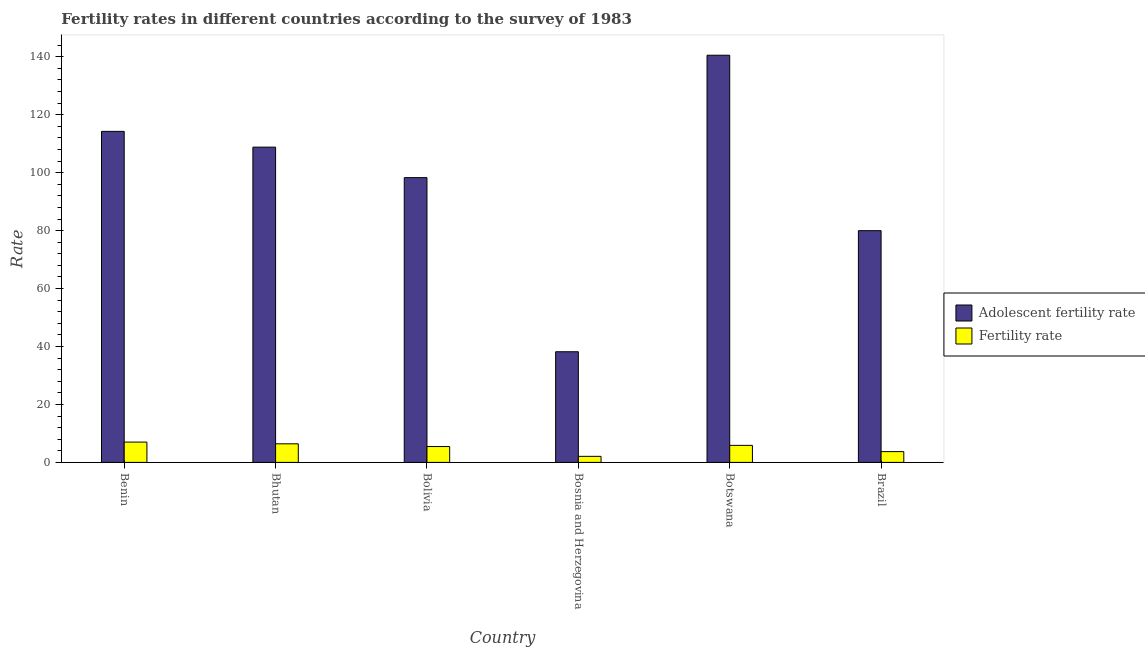How many different coloured bars are there?
Provide a short and direct response. 2. How many groups of bars are there?
Offer a very short reply. 6. Are the number of bars per tick equal to the number of legend labels?
Provide a succinct answer. Yes. Are the number of bars on each tick of the X-axis equal?
Make the answer very short. Yes. How many bars are there on the 6th tick from the right?
Provide a succinct answer. 2. What is the label of the 6th group of bars from the left?
Make the answer very short. Brazil. What is the fertility rate in Benin?
Keep it short and to the point. 7.01. Across all countries, what is the maximum fertility rate?
Ensure brevity in your answer.  7.01. Across all countries, what is the minimum fertility rate?
Keep it short and to the point. 2.09. In which country was the fertility rate maximum?
Your response must be concise. Benin. In which country was the fertility rate minimum?
Give a very brief answer. Bosnia and Herzegovina. What is the total fertility rate in the graph?
Offer a very short reply. 30.58. What is the difference between the adolescent fertility rate in Bosnia and Herzegovina and that in Brazil?
Your response must be concise. -41.79. What is the difference between the fertility rate in Bhutan and the adolescent fertility rate in Bosnia and Herzegovina?
Make the answer very short. -31.78. What is the average adolescent fertility rate per country?
Make the answer very short. 96.68. What is the difference between the adolescent fertility rate and fertility rate in Benin?
Ensure brevity in your answer.  107.25. In how many countries, is the adolescent fertility rate greater than 8 ?
Your answer should be very brief. 6. What is the ratio of the fertility rate in Bhutan to that in Botswana?
Provide a short and direct response. 1.09. Is the difference between the fertility rate in Bhutan and Brazil greater than the difference between the adolescent fertility rate in Bhutan and Brazil?
Your answer should be compact. No. What is the difference between the highest and the second highest adolescent fertility rate?
Ensure brevity in your answer.  26.28. What is the difference between the highest and the lowest fertility rate?
Offer a very short reply. 4.92. In how many countries, is the fertility rate greater than the average fertility rate taken over all countries?
Give a very brief answer. 4. What does the 2nd bar from the left in Brazil represents?
Your answer should be compact. Fertility rate. What does the 2nd bar from the right in Brazil represents?
Keep it short and to the point. Adolescent fertility rate. Are all the bars in the graph horizontal?
Provide a succinct answer. No. What is the difference between two consecutive major ticks on the Y-axis?
Make the answer very short. 20. Are the values on the major ticks of Y-axis written in scientific E-notation?
Keep it short and to the point. No. Does the graph contain grids?
Your answer should be compact. No. What is the title of the graph?
Give a very brief answer. Fertility rates in different countries according to the survey of 1983. What is the label or title of the X-axis?
Your answer should be very brief. Country. What is the label or title of the Y-axis?
Your answer should be very brief. Rate. What is the Rate in Adolescent fertility rate in Benin?
Offer a very short reply. 114.26. What is the Rate of Fertility rate in Benin?
Your answer should be very brief. 7.01. What is the Rate in Adolescent fertility rate in Bhutan?
Your answer should be very brief. 108.82. What is the Rate of Fertility rate in Bhutan?
Offer a terse response. 6.41. What is the Rate of Adolescent fertility rate in Bolivia?
Provide a short and direct response. 98.29. What is the Rate in Fertility rate in Bolivia?
Give a very brief answer. 5.47. What is the Rate of Adolescent fertility rate in Bosnia and Herzegovina?
Ensure brevity in your answer.  38.19. What is the Rate of Fertility rate in Bosnia and Herzegovina?
Your answer should be very brief. 2.09. What is the Rate of Adolescent fertility rate in Botswana?
Give a very brief answer. 140.54. What is the Rate in Fertility rate in Botswana?
Ensure brevity in your answer.  5.88. What is the Rate of Adolescent fertility rate in Brazil?
Offer a very short reply. 79.99. What is the Rate of Fertility rate in Brazil?
Offer a very short reply. 3.72. Across all countries, what is the maximum Rate in Adolescent fertility rate?
Your answer should be very brief. 140.54. Across all countries, what is the maximum Rate in Fertility rate?
Give a very brief answer. 7.01. Across all countries, what is the minimum Rate in Adolescent fertility rate?
Ensure brevity in your answer.  38.19. Across all countries, what is the minimum Rate of Fertility rate?
Make the answer very short. 2.09. What is the total Rate of Adolescent fertility rate in the graph?
Provide a succinct answer. 580.1. What is the total Rate of Fertility rate in the graph?
Ensure brevity in your answer.  30.58. What is the difference between the Rate in Adolescent fertility rate in Benin and that in Bhutan?
Your answer should be very brief. 5.44. What is the difference between the Rate of Fertility rate in Benin and that in Bhutan?
Give a very brief answer. 0.6. What is the difference between the Rate of Adolescent fertility rate in Benin and that in Bolivia?
Your answer should be compact. 15.97. What is the difference between the Rate of Fertility rate in Benin and that in Bolivia?
Provide a succinct answer. 1.54. What is the difference between the Rate of Adolescent fertility rate in Benin and that in Bosnia and Herzegovina?
Offer a very short reply. 76.07. What is the difference between the Rate in Fertility rate in Benin and that in Bosnia and Herzegovina?
Your response must be concise. 4.92. What is the difference between the Rate of Adolescent fertility rate in Benin and that in Botswana?
Ensure brevity in your answer.  -26.28. What is the difference between the Rate of Fertility rate in Benin and that in Botswana?
Offer a very short reply. 1.13. What is the difference between the Rate of Adolescent fertility rate in Benin and that in Brazil?
Ensure brevity in your answer.  34.28. What is the difference between the Rate of Fertility rate in Benin and that in Brazil?
Offer a terse response. 3.29. What is the difference between the Rate of Adolescent fertility rate in Bhutan and that in Bolivia?
Offer a terse response. 10.53. What is the difference between the Rate in Fertility rate in Bhutan and that in Bolivia?
Your answer should be compact. 0.94. What is the difference between the Rate of Adolescent fertility rate in Bhutan and that in Bosnia and Herzegovina?
Make the answer very short. 70.63. What is the difference between the Rate in Fertility rate in Bhutan and that in Bosnia and Herzegovina?
Give a very brief answer. 4.32. What is the difference between the Rate in Adolescent fertility rate in Bhutan and that in Botswana?
Your response must be concise. -31.72. What is the difference between the Rate in Fertility rate in Bhutan and that in Botswana?
Give a very brief answer. 0.53. What is the difference between the Rate in Adolescent fertility rate in Bhutan and that in Brazil?
Your response must be concise. 28.83. What is the difference between the Rate of Fertility rate in Bhutan and that in Brazil?
Offer a very short reply. 2.69. What is the difference between the Rate in Adolescent fertility rate in Bolivia and that in Bosnia and Herzegovina?
Provide a short and direct response. 60.1. What is the difference between the Rate of Fertility rate in Bolivia and that in Bosnia and Herzegovina?
Make the answer very short. 3.39. What is the difference between the Rate of Adolescent fertility rate in Bolivia and that in Botswana?
Offer a very short reply. -42.25. What is the difference between the Rate of Fertility rate in Bolivia and that in Botswana?
Provide a succinct answer. -0.41. What is the difference between the Rate in Adolescent fertility rate in Bolivia and that in Brazil?
Your answer should be compact. 18.31. What is the difference between the Rate in Fertility rate in Bolivia and that in Brazil?
Provide a succinct answer. 1.75. What is the difference between the Rate in Adolescent fertility rate in Bosnia and Herzegovina and that in Botswana?
Offer a very short reply. -102.35. What is the difference between the Rate of Fertility rate in Bosnia and Herzegovina and that in Botswana?
Ensure brevity in your answer.  -3.79. What is the difference between the Rate of Adolescent fertility rate in Bosnia and Herzegovina and that in Brazil?
Keep it short and to the point. -41.79. What is the difference between the Rate in Fertility rate in Bosnia and Herzegovina and that in Brazil?
Give a very brief answer. -1.64. What is the difference between the Rate in Adolescent fertility rate in Botswana and that in Brazil?
Make the answer very short. 60.56. What is the difference between the Rate of Fertility rate in Botswana and that in Brazil?
Offer a terse response. 2.16. What is the difference between the Rate of Adolescent fertility rate in Benin and the Rate of Fertility rate in Bhutan?
Your answer should be compact. 107.85. What is the difference between the Rate in Adolescent fertility rate in Benin and the Rate in Fertility rate in Bolivia?
Keep it short and to the point. 108.79. What is the difference between the Rate of Adolescent fertility rate in Benin and the Rate of Fertility rate in Bosnia and Herzegovina?
Give a very brief answer. 112.18. What is the difference between the Rate of Adolescent fertility rate in Benin and the Rate of Fertility rate in Botswana?
Your answer should be very brief. 108.38. What is the difference between the Rate of Adolescent fertility rate in Benin and the Rate of Fertility rate in Brazil?
Offer a very short reply. 110.54. What is the difference between the Rate of Adolescent fertility rate in Bhutan and the Rate of Fertility rate in Bolivia?
Give a very brief answer. 103.35. What is the difference between the Rate of Adolescent fertility rate in Bhutan and the Rate of Fertility rate in Bosnia and Herzegovina?
Keep it short and to the point. 106.73. What is the difference between the Rate in Adolescent fertility rate in Bhutan and the Rate in Fertility rate in Botswana?
Offer a very short reply. 102.94. What is the difference between the Rate of Adolescent fertility rate in Bhutan and the Rate of Fertility rate in Brazil?
Your response must be concise. 105.1. What is the difference between the Rate in Adolescent fertility rate in Bolivia and the Rate in Fertility rate in Bosnia and Herzegovina?
Your response must be concise. 96.21. What is the difference between the Rate of Adolescent fertility rate in Bolivia and the Rate of Fertility rate in Botswana?
Your answer should be very brief. 92.41. What is the difference between the Rate in Adolescent fertility rate in Bolivia and the Rate in Fertility rate in Brazil?
Ensure brevity in your answer.  94.57. What is the difference between the Rate in Adolescent fertility rate in Bosnia and Herzegovina and the Rate in Fertility rate in Botswana?
Offer a terse response. 32.31. What is the difference between the Rate of Adolescent fertility rate in Bosnia and Herzegovina and the Rate of Fertility rate in Brazil?
Make the answer very short. 34.47. What is the difference between the Rate of Adolescent fertility rate in Botswana and the Rate of Fertility rate in Brazil?
Your response must be concise. 136.82. What is the average Rate of Adolescent fertility rate per country?
Give a very brief answer. 96.68. What is the average Rate in Fertility rate per country?
Offer a very short reply. 5.1. What is the difference between the Rate in Adolescent fertility rate and Rate in Fertility rate in Benin?
Your answer should be compact. 107.25. What is the difference between the Rate of Adolescent fertility rate and Rate of Fertility rate in Bhutan?
Provide a short and direct response. 102.41. What is the difference between the Rate of Adolescent fertility rate and Rate of Fertility rate in Bolivia?
Your response must be concise. 92.82. What is the difference between the Rate in Adolescent fertility rate and Rate in Fertility rate in Bosnia and Herzegovina?
Offer a very short reply. 36.11. What is the difference between the Rate in Adolescent fertility rate and Rate in Fertility rate in Botswana?
Offer a very short reply. 134.66. What is the difference between the Rate of Adolescent fertility rate and Rate of Fertility rate in Brazil?
Your answer should be very brief. 76.27. What is the ratio of the Rate in Fertility rate in Benin to that in Bhutan?
Give a very brief answer. 1.09. What is the ratio of the Rate in Adolescent fertility rate in Benin to that in Bolivia?
Your answer should be very brief. 1.16. What is the ratio of the Rate of Fertility rate in Benin to that in Bolivia?
Keep it short and to the point. 1.28. What is the ratio of the Rate in Adolescent fertility rate in Benin to that in Bosnia and Herzegovina?
Your response must be concise. 2.99. What is the ratio of the Rate in Fertility rate in Benin to that in Bosnia and Herzegovina?
Give a very brief answer. 3.36. What is the ratio of the Rate in Adolescent fertility rate in Benin to that in Botswana?
Provide a succinct answer. 0.81. What is the ratio of the Rate of Fertility rate in Benin to that in Botswana?
Provide a succinct answer. 1.19. What is the ratio of the Rate of Adolescent fertility rate in Benin to that in Brazil?
Keep it short and to the point. 1.43. What is the ratio of the Rate in Fertility rate in Benin to that in Brazil?
Offer a terse response. 1.88. What is the ratio of the Rate of Adolescent fertility rate in Bhutan to that in Bolivia?
Offer a terse response. 1.11. What is the ratio of the Rate in Fertility rate in Bhutan to that in Bolivia?
Provide a short and direct response. 1.17. What is the ratio of the Rate of Adolescent fertility rate in Bhutan to that in Bosnia and Herzegovina?
Offer a very short reply. 2.85. What is the ratio of the Rate of Fertility rate in Bhutan to that in Bosnia and Herzegovina?
Your response must be concise. 3.07. What is the ratio of the Rate in Adolescent fertility rate in Bhutan to that in Botswana?
Keep it short and to the point. 0.77. What is the ratio of the Rate of Fertility rate in Bhutan to that in Botswana?
Provide a succinct answer. 1.09. What is the ratio of the Rate of Adolescent fertility rate in Bhutan to that in Brazil?
Provide a short and direct response. 1.36. What is the ratio of the Rate of Fertility rate in Bhutan to that in Brazil?
Offer a terse response. 1.72. What is the ratio of the Rate in Adolescent fertility rate in Bolivia to that in Bosnia and Herzegovina?
Make the answer very short. 2.57. What is the ratio of the Rate of Fertility rate in Bolivia to that in Bosnia and Herzegovina?
Provide a succinct answer. 2.62. What is the ratio of the Rate in Adolescent fertility rate in Bolivia to that in Botswana?
Offer a very short reply. 0.7. What is the ratio of the Rate of Fertility rate in Bolivia to that in Botswana?
Your answer should be very brief. 0.93. What is the ratio of the Rate of Adolescent fertility rate in Bolivia to that in Brazil?
Offer a very short reply. 1.23. What is the ratio of the Rate in Fertility rate in Bolivia to that in Brazil?
Provide a short and direct response. 1.47. What is the ratio of the Rate of Adolescent fertility rate in Bosnia and Herzegovina to that in Botswana?
Give a very brief answer. 0.27. What is the ratio of the Rate in Fertility rate in Bosnia and Herzegovina to that in Botswana?
Keep it short and to the point. 0.35. What is the ratio of the Rate in Adolescent fertility rate in Bosnia and Herzegovina to that in Brazil?
Make the answer very short. 0.48. What is the ratio of the Rate in Fertility rate in Bosnia and Herzegovina to that in Brazil?
Your answer should be compact. 0.56. What is the ratio of the Rate in Adolescent fertility rate in Botswana to that in Brazil?
Offer a terse response. 1.76. What is the ratio of the Rate of Fertility rate in Botswana to that in Brazil?
Provide a short and direct response. 1.58. What is the difference between the highest and the second highest Rate of Adolescent fertility rate?
Make the answer very short. 26.28. What is the difference between the highest and the lowest Rate of Adolescent fertility rate?
Your response must be concise. 102.35. What is the difference between the highest and the lowest Rate of Fertility rate?
Your answer should be very brief. 4.92. 